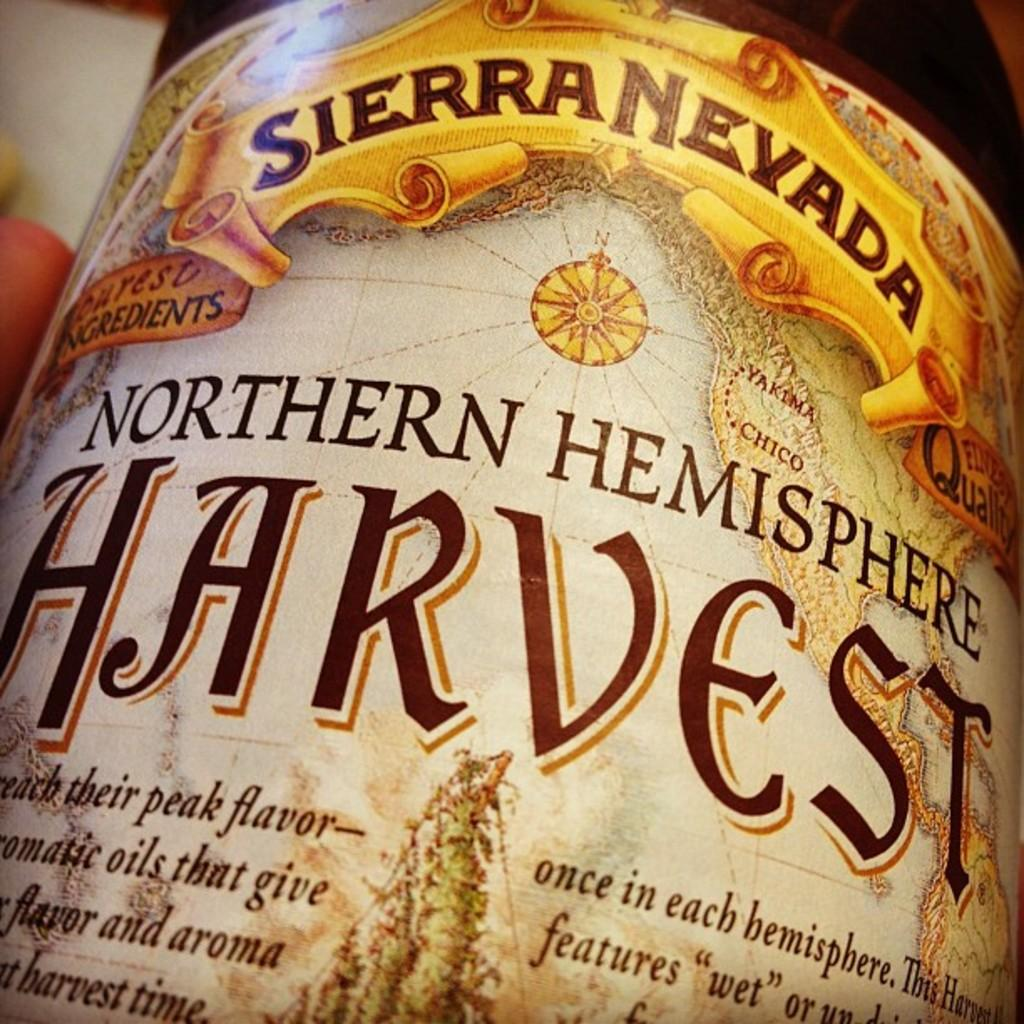What is the main object in the center of the image? There is a bottle in the center of the image. What can be found on the bottle? There is text written on the bottle. How does the comb help to create bubbles in the image? There is no comb present in the image, and therefore no bubbles are being created. 